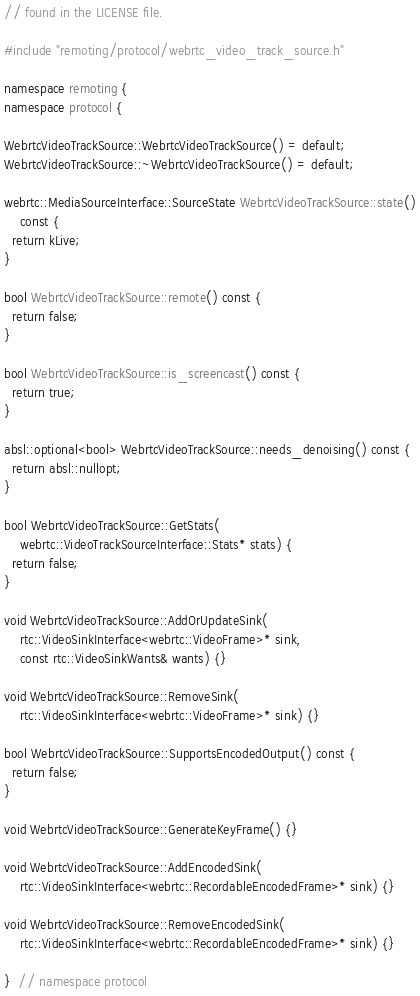Convert code to text. <code><loc_0><loc_0><loc_500><loc_500><_C++_>// found in the LICENSE file.

#include "remoting/protocol/webrtc_video_track_source.h"

namespace remoting {
namespace protocol {

WebrtcVideoTrackSource::WebrtcVideoTrackSource() = default;
WebrtcVideoTrackSource::~WebrtcVideoTrackSource() = default;

webrtc::MediaSourceInterface::SourceState WebrtcVideoTrackSource::state()
    const {
  return kLive;
}

bool WebrtcVideoTrackSource::remote() const {
  return false;
}

bool WebrtcVideoTrackSource::is_screencast() const {
  return true;
}

absl::optional<bool> WebrtcVideoTrackSource::needs_denoising() const {
  return absl::nullopt;
}

bool WebrtcVideoTrackSource::GetStats(
    webrtc::VideoTrackSourceInterface::Stats* stats) {
  return false;
}

void WebrtcVideoTrackSource::AddOrUpdateSink(
    rtc::VideoSinkInterface<webrtc::VideoFrame>* sink,
    const rtc::VideoSinkWants& wants) {}

void WebrtcVideoTrackSource::RemoveSink(
    rtc::VideoSinkInterface<webrtc::VideoFrame>* sink) {}

bool WebrtcVideoTrackSource::SupportsEncodedOutput() const {
  return false;
}

void WebrtcVideoTrackSource::GenerateKeyFrame() {}

void WebrtcVideoTrackSource::AddEncodedSink(
    rtc::VideoSinkInterface<webrtc::RecordableEncodedFrame>* sink) {}

void WebrtcVideoTrackSource::RemoveEncodedSink(
    rtc::VideoSinkInterface<webrtc::RecordableEncodedFrame>* sink) {}

}  // namespace protocol</code> 